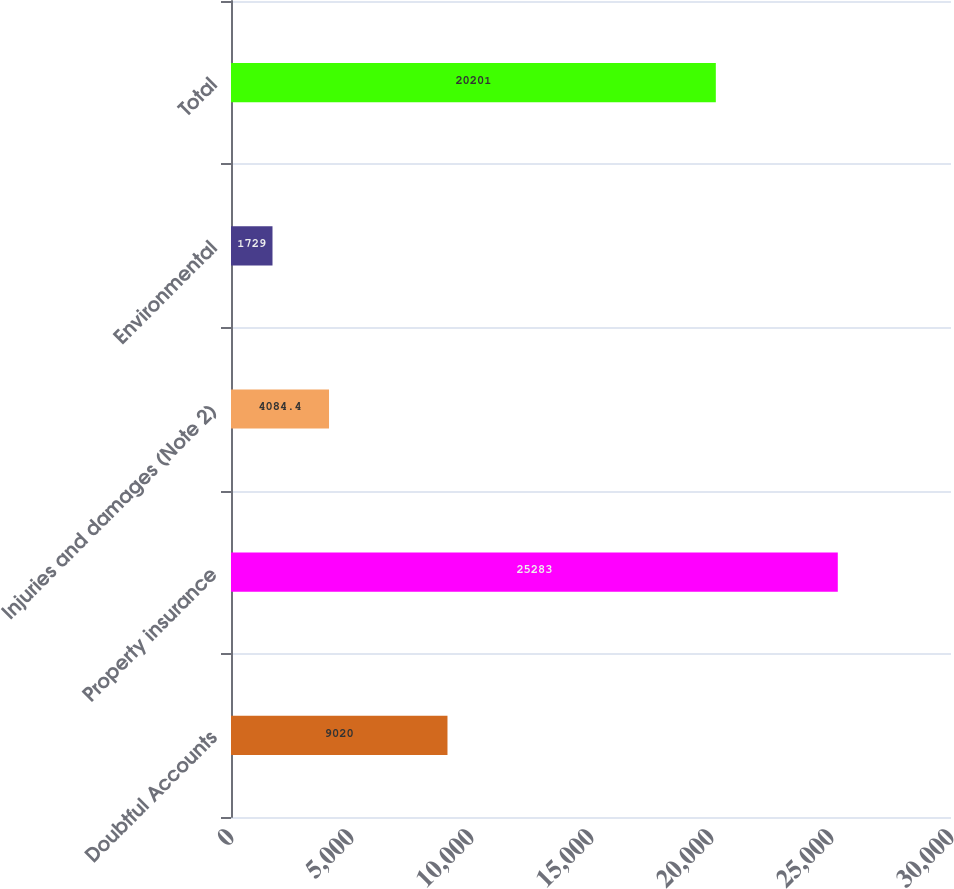Convert chart to OTSL. <chart><loc_0><loc_0><loc_500><loc_500><bar_chart><fcel>Doubtful Accounts<fcel>Property insurance<fcel>Injuries and damages (Note 2)<fcel>Environmental<fcel>Total<nl><fcel>9020<fcel>25283<fcel>4084.4<fcel>1729<fcel>20201<nl></chart> 